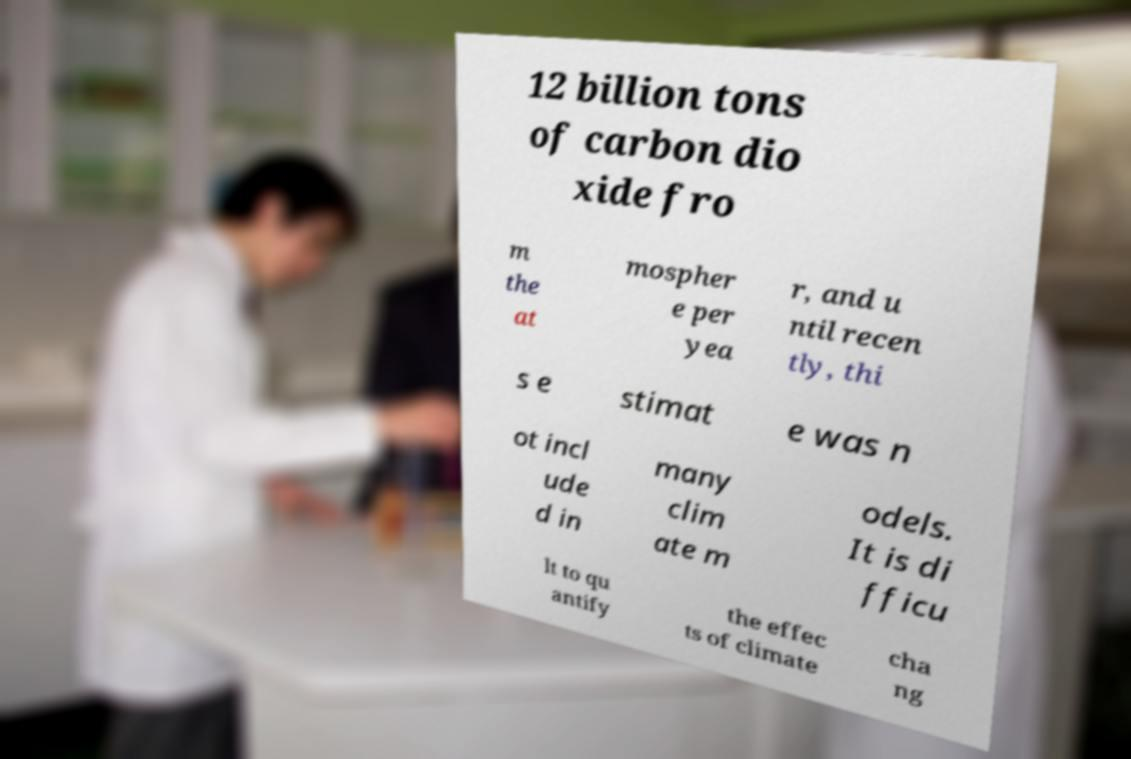I need the written content from this picture converted into text. Can you do that? 12 billion tons of carbon dio xide fro m the at mospher e per yea r, and u ntil recen tly, thi s e stimat e was n ot incl ude d in many clim ate m odels. It is di fficu lt to qu antify the effec ts of climate cha ng 